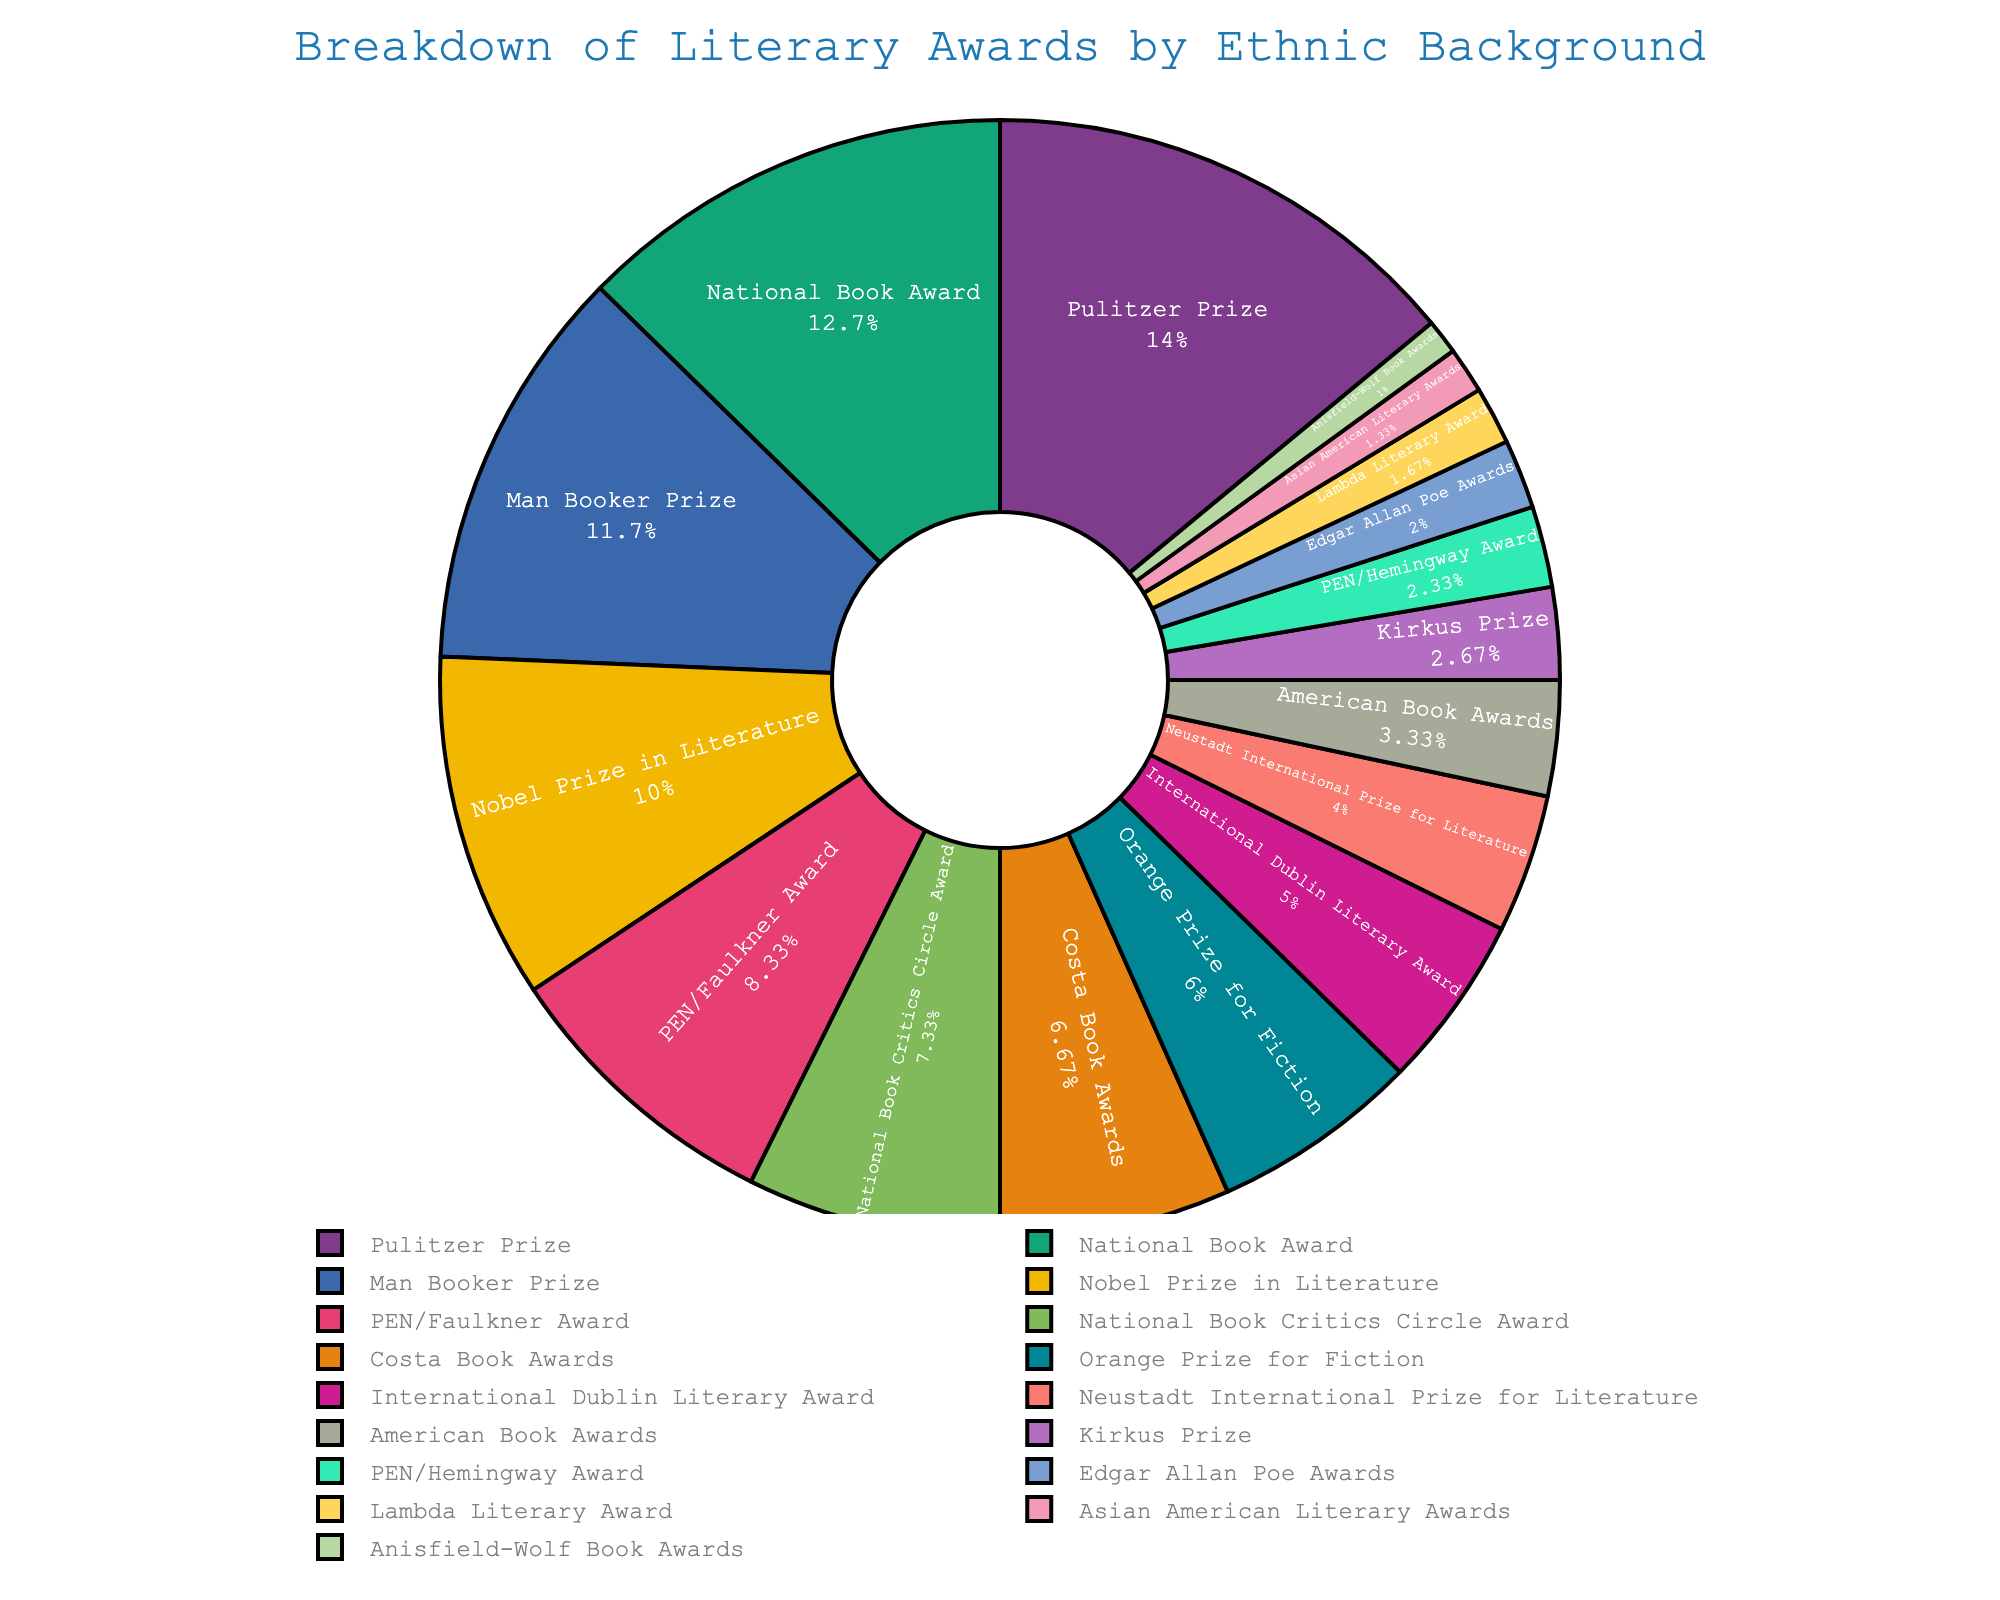Which literary award has the highest percentage? By visually inspecting the pie chart, the Pulitzer Prize occupies the largest segment.
Answer: Pulitzer Prize Which award represents the smallest percentage? By looking at the smallest slice in the pie chart, the Anisfield-Wolf Book Awards segment is the smallest.
Answer: Anisfield-Wolf Book Awards What is the combined percentage of the National Book Award and the Man Booker Prize? Adding the percentages of the National Book Award (38%) and the Man Booker Prize (35%) gives 38 + 35 = 73%.
Answer: 73% How does the percentage of the Nobel Prize in Literature compare to that of the Costa Book Awards? The Nobel Prize in Literature has a percentage of 30% which is higher than the Costa Book Awards at 20%.
Answer: Higher Are there more awards above 25% or below 25%? Above 25%: Pulitzer Prize (42%), National Book Award (38%), Man Booker Prize (35%), Nobel Prize in Literature (30%) – total 4 awards. Below 25%: PEN/Faulkner Award (25%), National Book Critics Circle Award (22%), Costa Book Awards (20%), Orange Prize for Fiction (18%), International Dublin Literary Award (15%), Neustadt International Prize for Literature (12%), American Book Awards (10%), Kirkus Prize (8%), PEN/Hemingway Award (7%), Edgar Allan Poe Awards (6%), Lambda Literary Award (5%), Asian American Literary Awards (4%), Anisfield-Wolf Book Awards (3%) – total 13 awards. Therefore, more awards are below 25%.
Answer: Below 25% Which award has a larger percentage, the Orange Prize for Fiction or the PEN/Faulkner Award? The Orange Prize for Fiction has 18% and the PEN/Faulkner Award has 25%, so the PEN/Faulkner Award has a larger percentage.
Answer: PEN/Faulkner Award How much larger is the percentage of the Pulitzer Prize than the Lambda Literary Award? Subtracting Lambda Literary Award's percentage (5%) from Pulitzer Prize (42%) gives 42 - 5 = 37%.
Answer: 37% What is the difference in percentage between the National Book Critics Circle Award and the Lambda Literary Award? Subtracting the Lambda Literary Award's percentage (5%) from the National Book Critics Circle Award (22%) gives 22 - 5 = 17%.
Answer: 17% What is the total percentage of the top four awards by percentage? Adding the percentages of the top four awards: Pulitzer Prize (42%), National Book Award (38%), Man Booker Prize (35%), Nobel Prize in Literature (30%) gives 42 + 38 + 35 + 30 = 145%.
Answer: 145% What's the average percentage of the Kirkus Prize, PEN/Hemingway Award, and Edgar Allan Poe Awards? Adding the percentages of Kirkus Prize (8%), PEN/Hemingway Award (7%), and Edgar Allan Poe Awards (6%) gives 8 + 7 + 6 = 21. Dividing by the number of awards (3) gives 21 / 3 = 7%.
Answer: 7% 